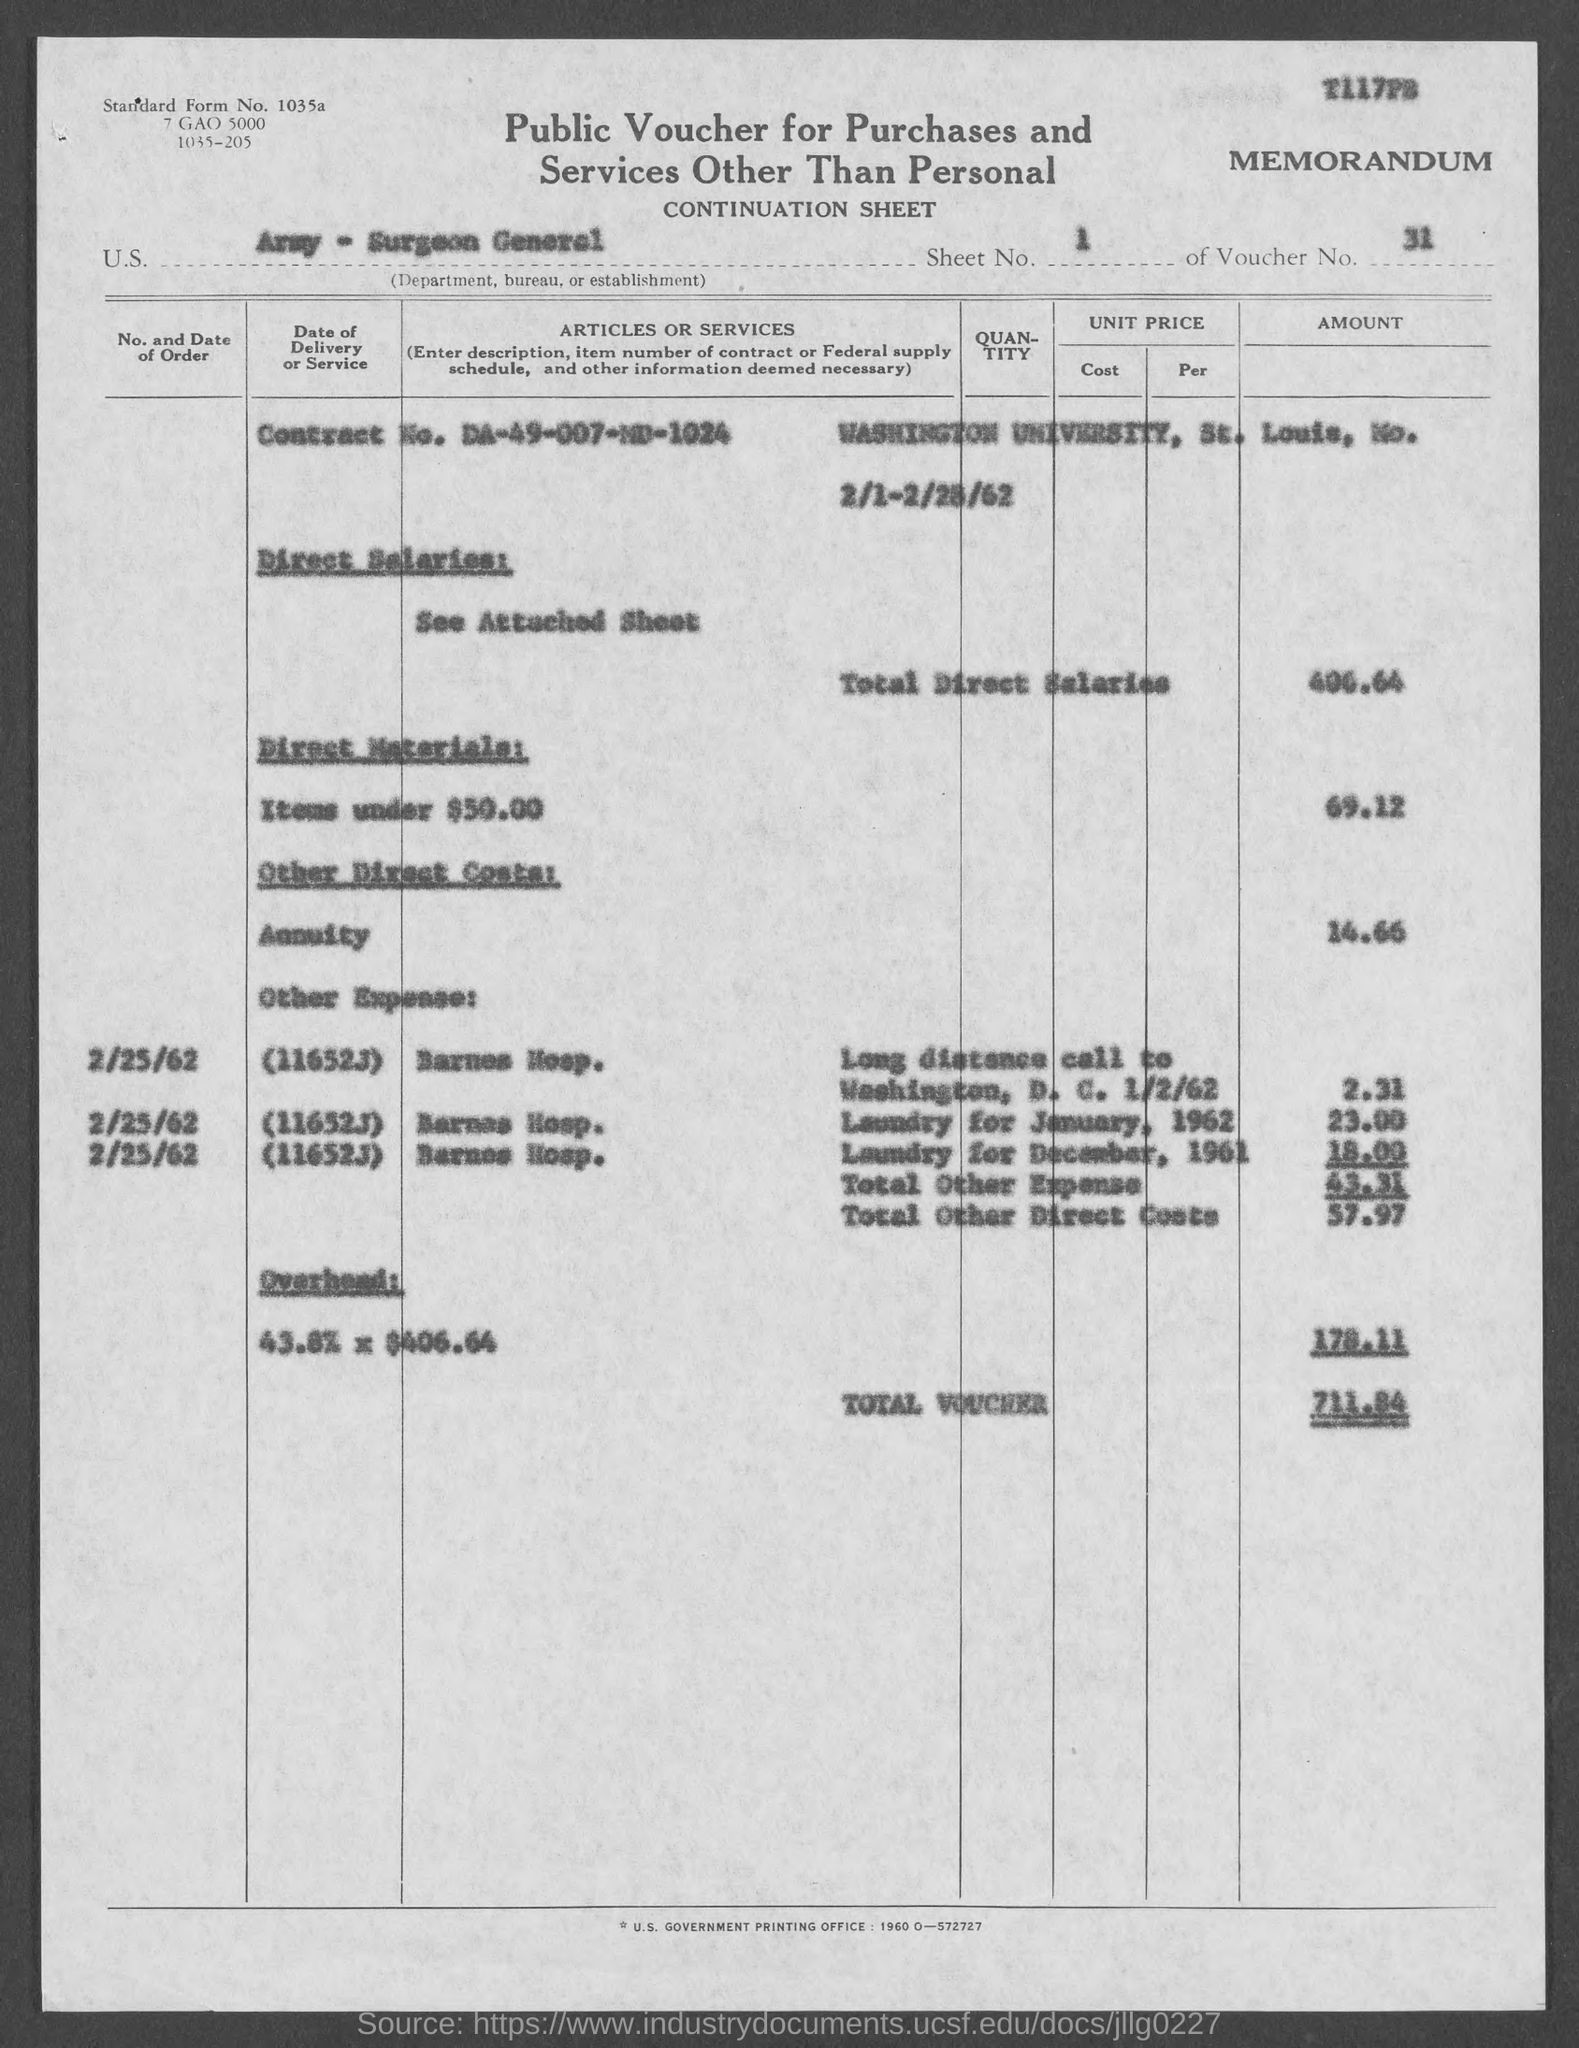What is the document title?
Your answer should be compact. Public Voucher for Purchases and Services Other Than Personal. What is the standard form no.?
Your answer should be very brief. 1035a. What is the sheet no.?
Your answer should be very brief. 1. What is the voucher number?
Keep it short and to the point. 31. What is the total voucher?
Give a very brief answer. 711.84. 